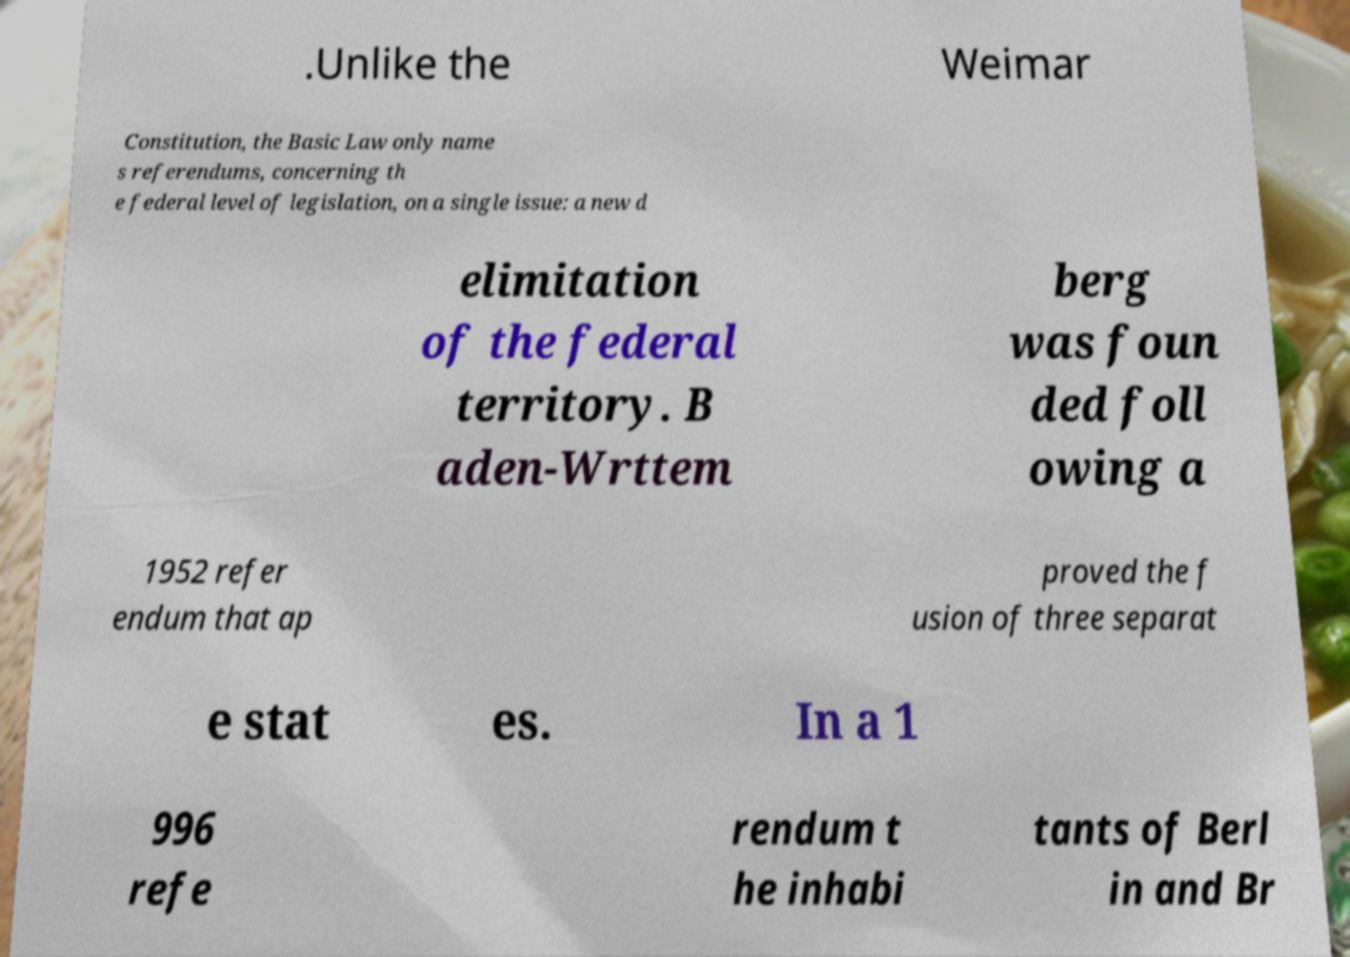Can you accurately transcribe the text from the provided image for me? .Unlike the Weimar Constitution, the Basic Law only name s referendums, concerning th e federal level of legislation, on a single issue: a new d elimitation of the federal territory. B aden-Wrttem berg was foun ded foll owing a 1952 refer endum that ap proved the f usion of three separat e stat es. In a 1 996 refe rendum t he inhabi tants of Berl in and Br 